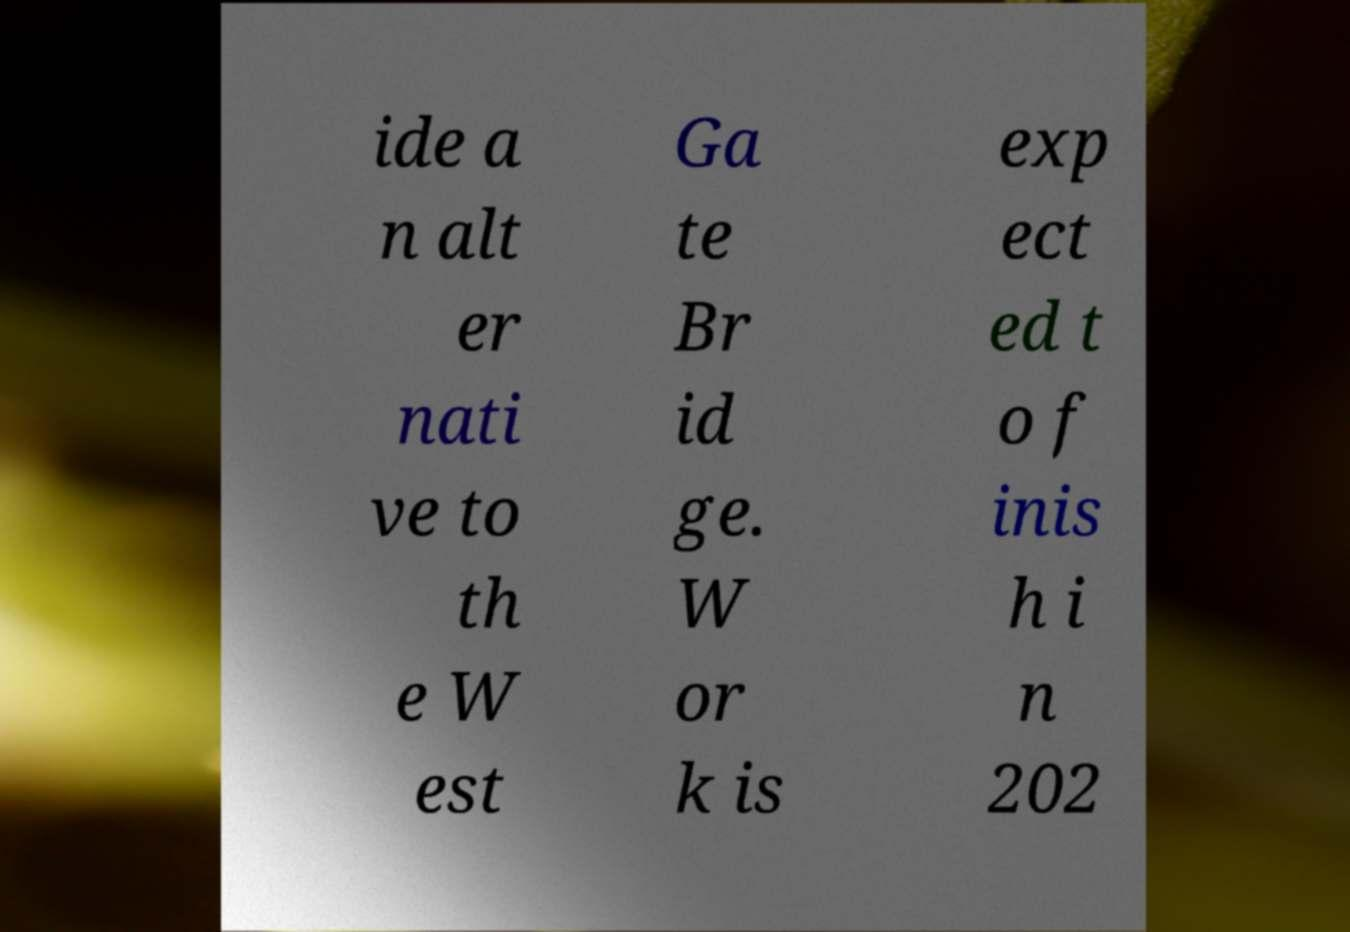I need the written content from this picture converted into text. Can you do that? ide a n alt er nati ve to th e W est Ga te Br id ge. W or k is exp ect ed t o f inis h i n 202 